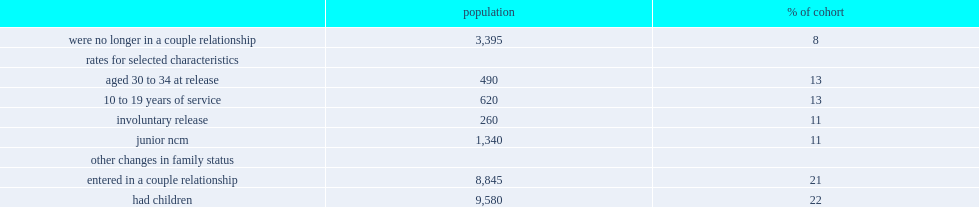What is the percentage of veterans had left their couple relationship (separated) during the first 3 years post-release one in five veterans? 11.0. What is the percentage of veterans had entered in a couple relationship during the first 3 years post-release one in five veterans? 21.0. What is the percentage of veterans had their first child during the first 3 years post-release one in five veterans? 22.0. What is the percentage of veterans who aged 30 to 34 had separation during the first 3 years post-release one in five veterans? 13.0. What is the percentage of veterans who who had 10 to 19 years of service had separation during the first 3 years post-release one in five veterans? 13.0. 